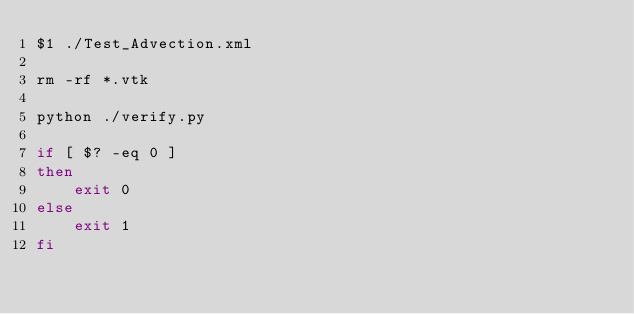<code> <loc_0><loc_0><loc_500><loc_500><_Bash_>$1 ./Test_Advection.xml

rm -rf *.vtk

python ./verify.py

if [ $? -eq 0 ]
then
    exit 0
else
    exit 1
fi
</code> 